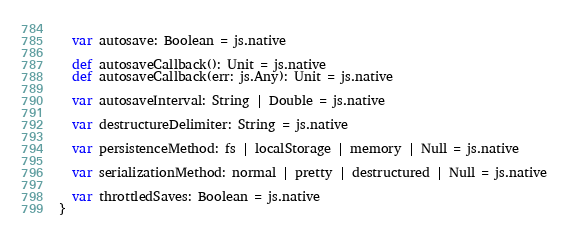Convert code to text. <code><loc_0><loc_0><loc_500><loc_500><_Scala_>  
  var autosave: Boolean = js.native
  
  def autosaveCallback(): Unit = js.native
  def autosaveCallback(err: js.Any): Unit = js.native
  
  var autosaveInterval: String | Double = js.native
  
  var destructureDelimiter: String = js.native
  
  var persistenceMethod: fs | localStorage | memory | Null = js.native
  
  var serializationMethod: normal | pretty | destructured | Null = js.native
  
  var throttledSaves: Boolean = js.native
}
</code> 